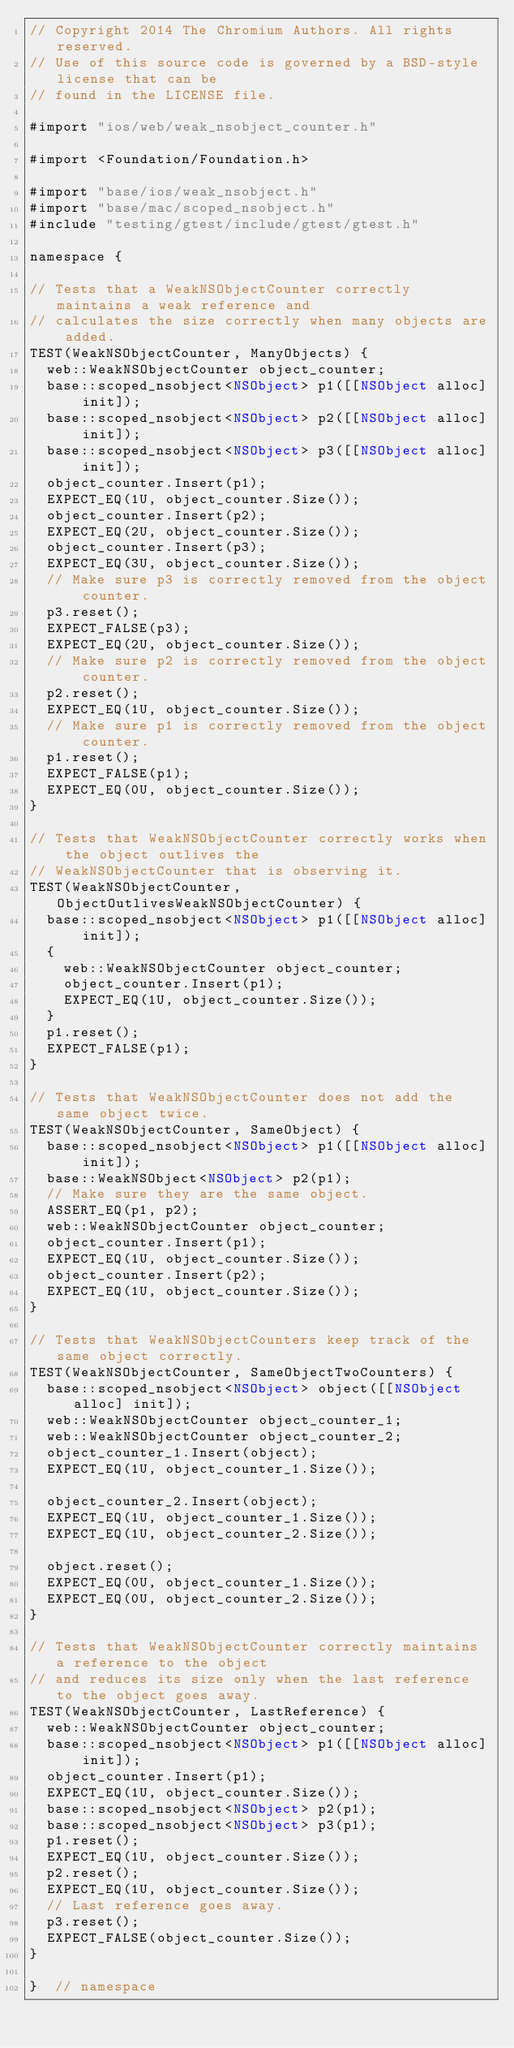Convert code to text. <code><loc_0><loc_0><loc_500><loc_500><_ObjectiveC_>// Copyright 2014 The Chromium Authors. All rights reserved.
// Use of this source code is governed by a BSD-style license that can be
// found in the LICENSE file.

#import "ios/web/weak_nsobject_counter.h"

#import <Foundation/Foundation.h>

#import "base/ios/weak_nsobject.h"
#import "base/mac/scoped_nsobject.h"
#include "testing/gtest/include/gtest/gtest.h"

namespace {

// Tests that a WeakNSObjectCounter correctly maintains a weak reference and
// calculates the size correctly when many objects are added.
TEST(WeakNSObjectCounter, ManyObjects) {
  web::WeakNSObjectCounter object_counter;
  base::scoped_nsobject<NSObject> p1([[NSObject alloc] init]);
  base::scoped_nsobject<NSObject> p2([[NSObject alloc] init]);
  base::scoped_nsobject<NSObject> p3([[NSObject alloc] init]);
  object_counter.Insert(p1);
  EXPECT_EQ(1U, object_counter.Size());
  object_counter.Insert(p2);
  EXPECT_EQ(2U, object_counter.Size());
  object_counter.Insert(p3);
  EXPECT_EQ(3U, object_counter.Size());
  // Make sure p3 is correctly removed from the object counter.
  p3.reset();
  EXPECT_FALSE(p3);
  EXPECT_EQ(2U, object_counter.Size());
  // Make sure p2 is correctly removed from the object counter.
  p2.reset();
  EXPECT_EQ(1U, object_counter.Size());
  // Make sure p1 is correctly removed from the object counter.
  p1.reset();
  EXPECT_FALSE(p1);
  EXPECT_EQ(0U, object_counter.Size());
}

// Tests that WeakNSObjectCounter correctly works when the object outlives the
// WeakNSObjectCounter that is observing it.
TEST(WeakNSObjectCounter, ObjectOutlivesWeakNSObjectCounter) {
  base::scoped_nsobject<NSObject> p1([[NSObject alloc] init]);
  {
    web::WeakNSObjectCounter object_counter;
    object_counter.Insert(p1);
    EXPECT_EQ(1U, object_counter.Size());
  }
  p1.reset();
  EXPECT_FALSE(p1);
}

// Tests that WeakNSObjectCounter does not add the same object twice.
TEST(WeakNSObjectCounter, SameObject) {
  base::scoped_nsobject<NSObject> p1([[NSObject alloc] init]);
  base::WeakNSObject<NSObject> p2(p1);
  // Make sure they are the same object.
  ASSERT_EQ(p1, p2);
  web::WeakNSObjectCounter object_counter;
  object_counter.Insert(p1);
  EXPECT_EQ(1U, object_counter.Size());
  object_counter.Insert(p2);
  EXPECT_EQ(1U, object_counter.Size());
}

// Tests that WeakNSObjectCounters keep track of the same object correctly.
TEST(WeakNSObjectCounter, SameObjectTwoCounters) {
  base::scoped_nsobject<NSObject> object([[NSObject alloc] init]);
  web::WeakNSObjectCounter object_counter_1;
  web::WeakNSObjectCounter object_counter_2;
  object_counter_1.Insert(object);
  EXPECT_EQ(1U, object_counter_1.Size());

  object_counter_2.Insert(object);
  EXPECT_EQ(1U, object_counter_1.Size());
  EXPECT_EQ(1U, object_counter_2.Size());

  object.reset();
  EXPECT_EQ(0U, object_counter_1.Size());
  EXPECT_EQ(0U, object_counter_2.Size());
}

// Tests that WeakNSObjectCounter correctly maintains a reference to the object
// and reduces its size only when the last reference to the object goes away.
TEST(WeakNSObjectCounter, LastReference) {
  web::WeakNSObjectCounter object_counter;
  base::scoped_nsobject<NSObject> p1([[NSObject alloc] init]);
  object_counter.Insert(p1);
  EXPECT_EQ(1U, object_counter.Size());
  base::scoped_nsobject<NSObject> p2(p1);
  base::scoped_nsobject<NSObject> p3(p1);
  p1.reset();
  EXPECT_EQ(1U, object_counter.Size());
  p2.reset();
  EXPECT_EQ(1U, object_counter.Size());
  // Last reference goes away.
  p3.reset();
  EXPECT_FALSE(object_counter.Size());
}

}  // namespace
</code> 